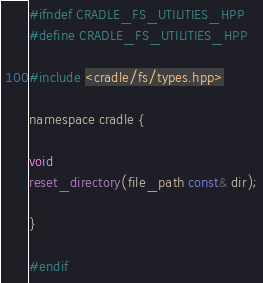Convert code to text. <code><loc_0><loc_0><loc_500><loc_500><_C_>#ifndef CRADLE_FS_UTILITIES_HPP
#define CRADLE_FS_UTILITIES_HPP

#include <cradle/fs/types.hpp>

namespace cradle {

void
reset_directory(file_path const& dir);

}

#endif
</code> 